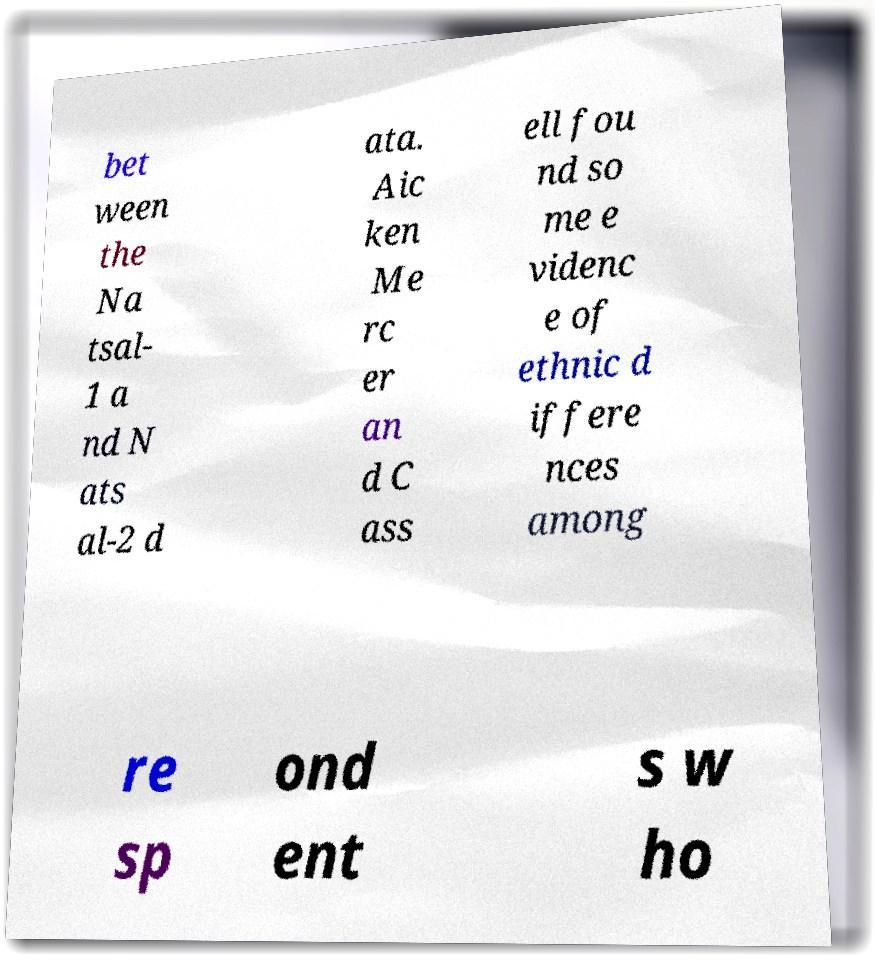Can you accurately transcribe the text from the provided image for me? bet ween the Na tsal- 1 a nd N ats al-2 d ata. Aic ken Me rc er an d C ass ell fou nd so me e videnc e of ethnic d iffere nces among re sp ond ent s w ho 